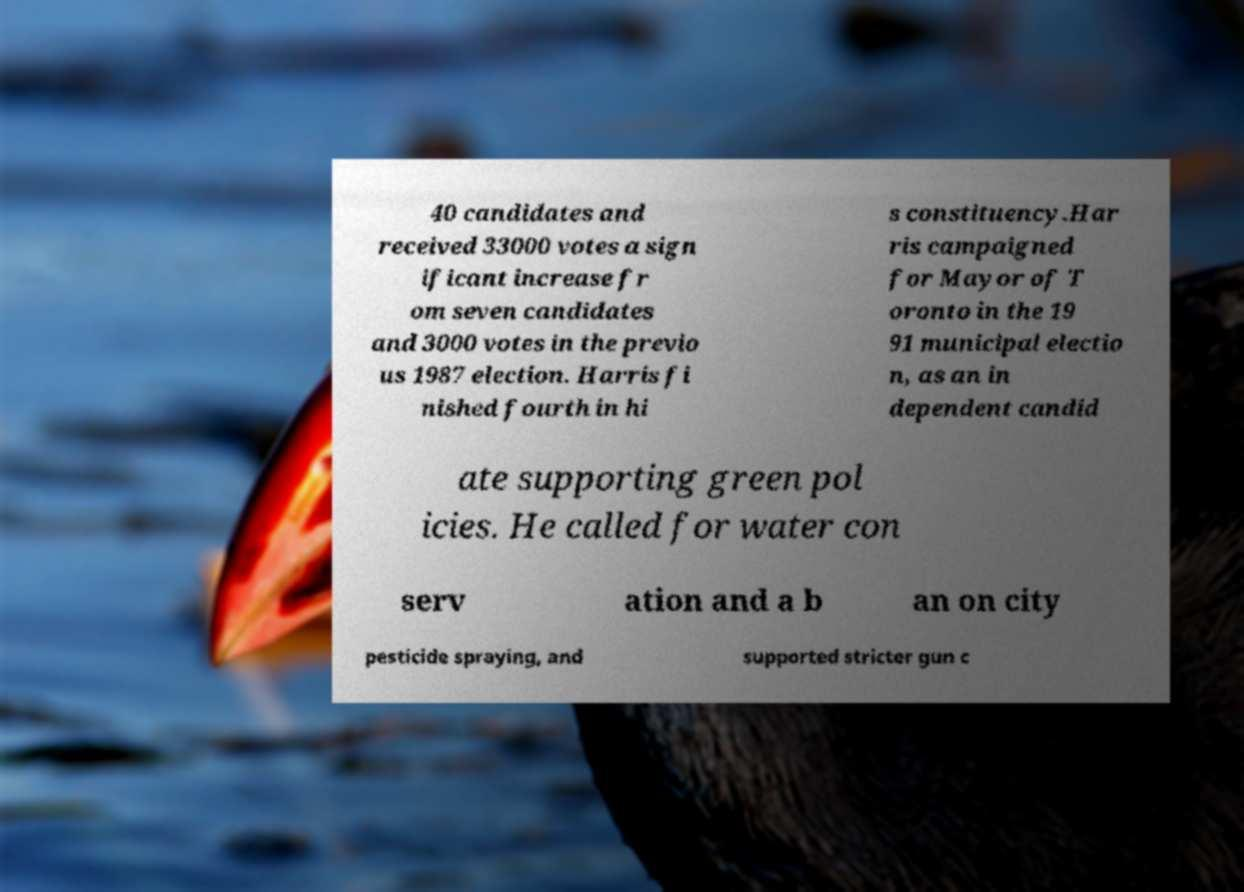Please read and relay the text visible in this image. What does it say? 40 candidates and received 33000 votes a sign ificant increase fr om seven candidates and 3000 votes in the previo us 1987 election. Harris fi nished fourth in hi s constituency.Har ris campaigned for Mayor of T oronto in the 19 91 municipal electio n, as an in dependent candid ate supporting green pol icies. He called for water con serv ation and a b an on city pesticide spraying, and supported stricter gun c 